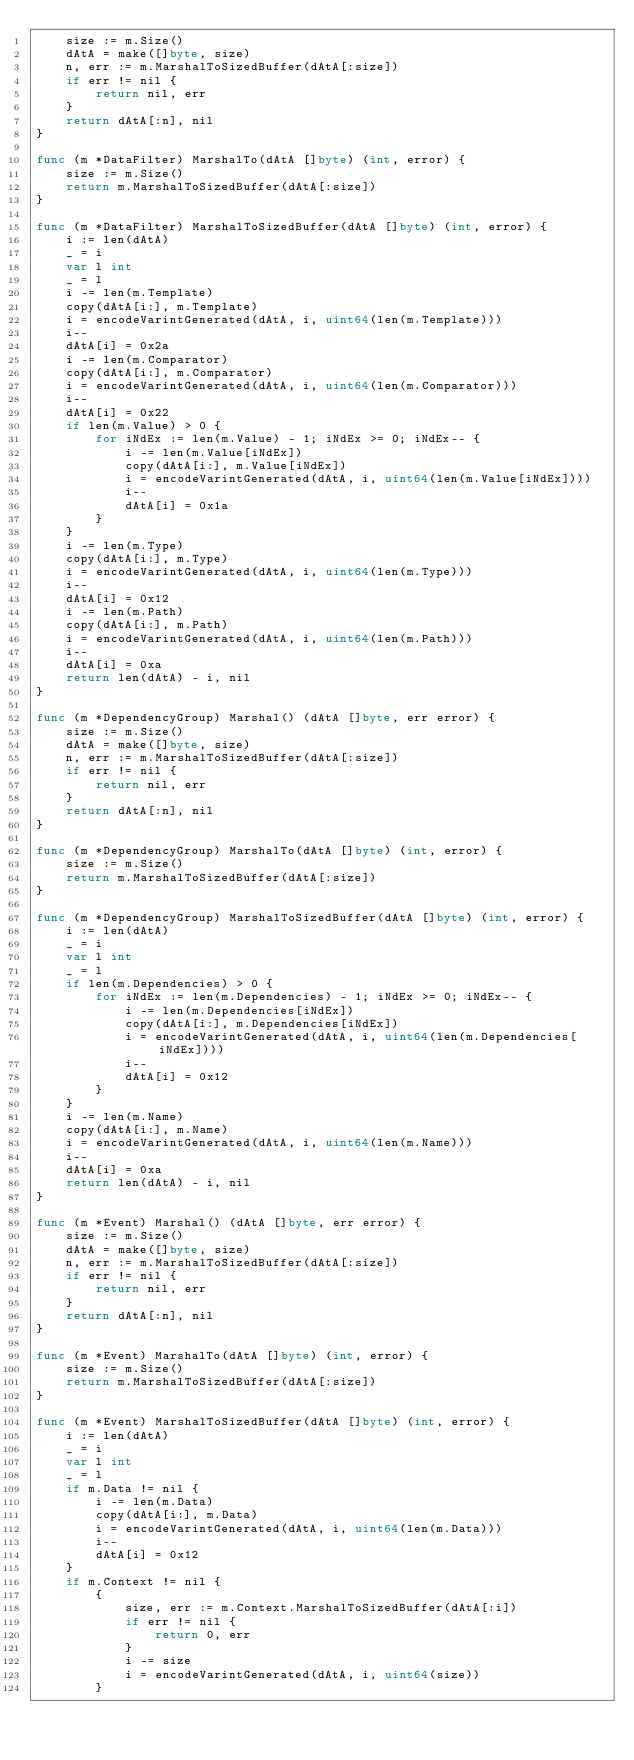<code> <loc_0><loc_0><loc_500><loc_500><_Go_>	size := m.Size()
	dAtA = make([]byte, size)
	n, err := m.MarshalToSizedBuffer(dAtA[:size])
	if err != nil {
		return nil, err
	}
	return dAtA[:n], nil
}

func (m *DataFilter) MarshalTo(dAtA []byte) (int, error) {
	size := m.Size()
	return m.MarshalToSizedBuffer(dAtA[:size])
}

func (m *DataFilter) MarshalToSizedBuffer(dAtA []byte) (int, error) {
	i := len(dAtA)
	_ = i
	var l int
	_ = l
	i -= len(m.Template)
	copy(dAtA[i:], m.Template)
	i = encodeVarintGenerated(dAtA, i, uint64(len(m.Template)))
	i--
	dAtA[i] = 0x2a
	i -= len(m.Comparator)
	copy(dAtA[i:], m.Comparator)
	i = encodeVarintGenerated(dAtA, i, uint64(len(m.Comparator)))
	i--
	dAtA[i] = 0x22
	if len(m.Value) > 0 {
		for iNdEx := len(m.Value) - 1; iNdEx >= 0; iNdEx-- {
			i -= len(m.Value[iNdEx])
			copy(dAtA[i:], m.Value[iNdEx])
			i = encodeVarintGenerated(dAtA, i, uint64(len(m.Value[iNdEx])))
			i--
			dAtA[i] = 0x1a
		}
	}
	i -= len(m.Type)
	copy(dAtA[i:], m.Type)
	i = encodeVarintGenerated(dAtA, i, uint64(len(m.Type)))
	i--
	dAtA[i] = 0x12
	i -= len(m.Path)
	copy(dAtA[i:], m.Path)
	i = encodeVarintGenerated(dAtA, i, uint64(len(m.Path)))
	i--
	dAtA[i] = 0xa
	return len(dAtA) - i, nil
}

func (m *DependencyGroup) Marshal() (dAtA []byte, err error) {
	size := m.Size()
	dAtA = make([]byte, size)
	n, err := m.MarshalToSizedBuffer(dAtA[:size])
	if err != nil {
		return nil, err
	}
	return dAtA[:n], nil
}

func (m *DependencyGroup) MarshalTo(dAtA []byte) (int, error) {
	size := m.Size()
	return m.MarshalToSizedBuffer(dAtA[:size])
}

func (m *DependencyGroup) MarshalToSizedBuffer(dAtA []byte) (int, error) {
	i := len(dAtA)
	_ = i
	var l int
	_ = l
	if len(m.Dependencies) > 0 {
		for iNdEx := len(m.Dependencies) - 1; iNdEx >= 0; iNdEx-- {
			i -= len(m.Dependencies[iNdEx])
			copy(dAtA[i:], m.Dependencies[iNdEx])
			i = encodeVarintGenerated(dAtA, i, uint64(len(m.Dependencies[iNdEx])))
			i--
			dAtA[i] = 0x12
		}
	}
	i -= len(m.Name)
	copy(dAtA[i:], m.Name)
	i = encodeVarintGenerated(dAtA, i, uint64(len(m.Name)))
	i--
	dAtA[i] = 0xa
	return len(dAtA) - i, nil
}

func (m *Event) Marshal() (dAtA []byte, err error) {
	size := m.Size()
	dAtA = make([]byte, size)
	n, err := m.MarshalToSizedBuffer(dAtA[:size])
	if err != nil {
		return nil, err
	}
	return dAtA[:n], nil
}

func (m *Event) MarshalTo(dAtA []byte) (int, error) {
	size := m.Size()
	return m.MarshalToSizedBuffer(dAtA[:size])
}

func (m *Event) MarshalToSizedBuffer(dAtA []byte) (int, error) {
	i := len(dAtA)
	_ = i
	var l int
	_ = l
	if m.Data != nil {
		i -= len(m.Data)
		copy(dAtA[i:], m.Data)
		i = encodeVarintGenerated(dAtA, i, uint64(len(m.Data)))
		i--
		dAtA[i] = 0x12
	}
	if m.Context != nil {
		{
			size, err := m.Context.MarshalToSizedBuffer(dAtA[:i])
			if err != nil {
				return 0, err
			}
			i -= size
			i = encodeVarintGenerated(dAtA, i, uint64(size))
		}</code> 